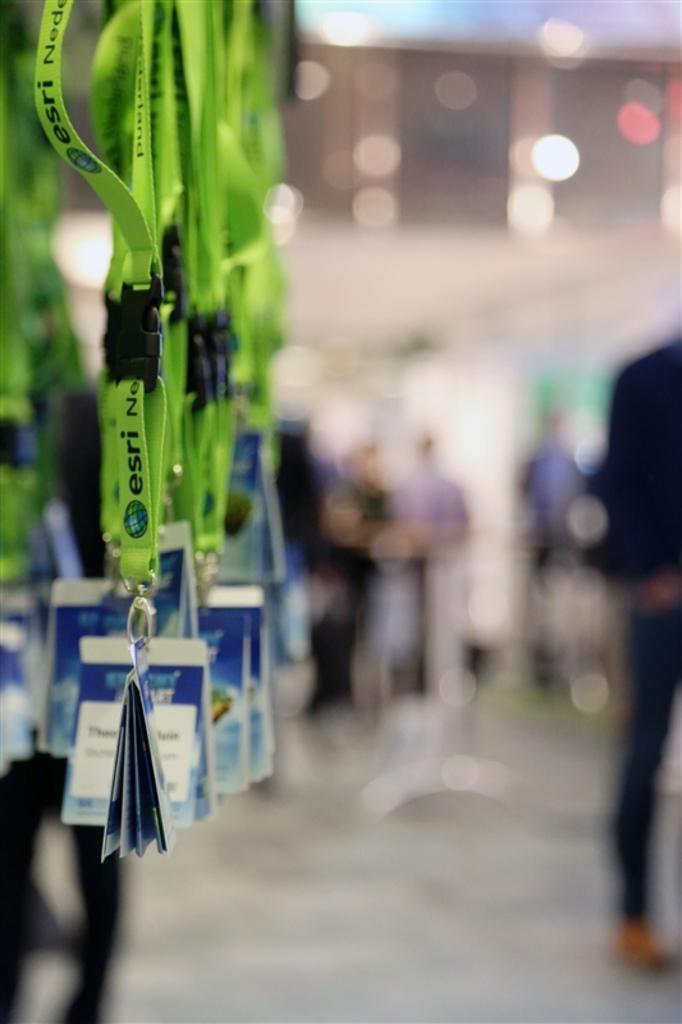What type of tags are visible in the image? There are green tags in the image. Can you describe the people in the background of the image? Unfortunately, the provided facts do not give any information about the people in the background. Are there any other objects or features visible in the image besides the green tags? The facts do not mention any other objects or features in the image. How many stems are attached to the green tags in the image? There is no mention of stems in the provided facts, so it is impossible to answer this question. 